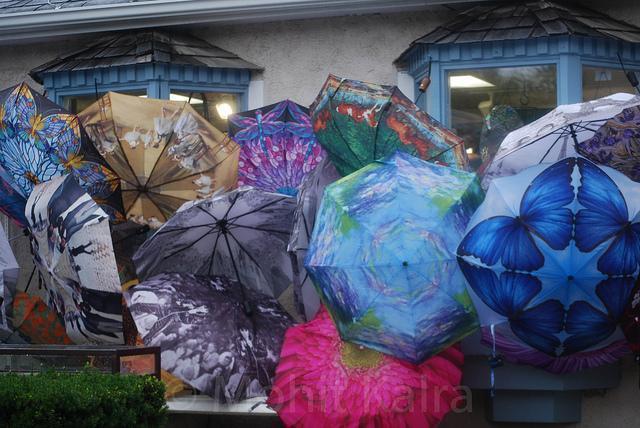How many blue umbrellas are there?
Give a very brief answer. 3. How many umbrellas are in the picture?
Give a very brief answer. 12. 